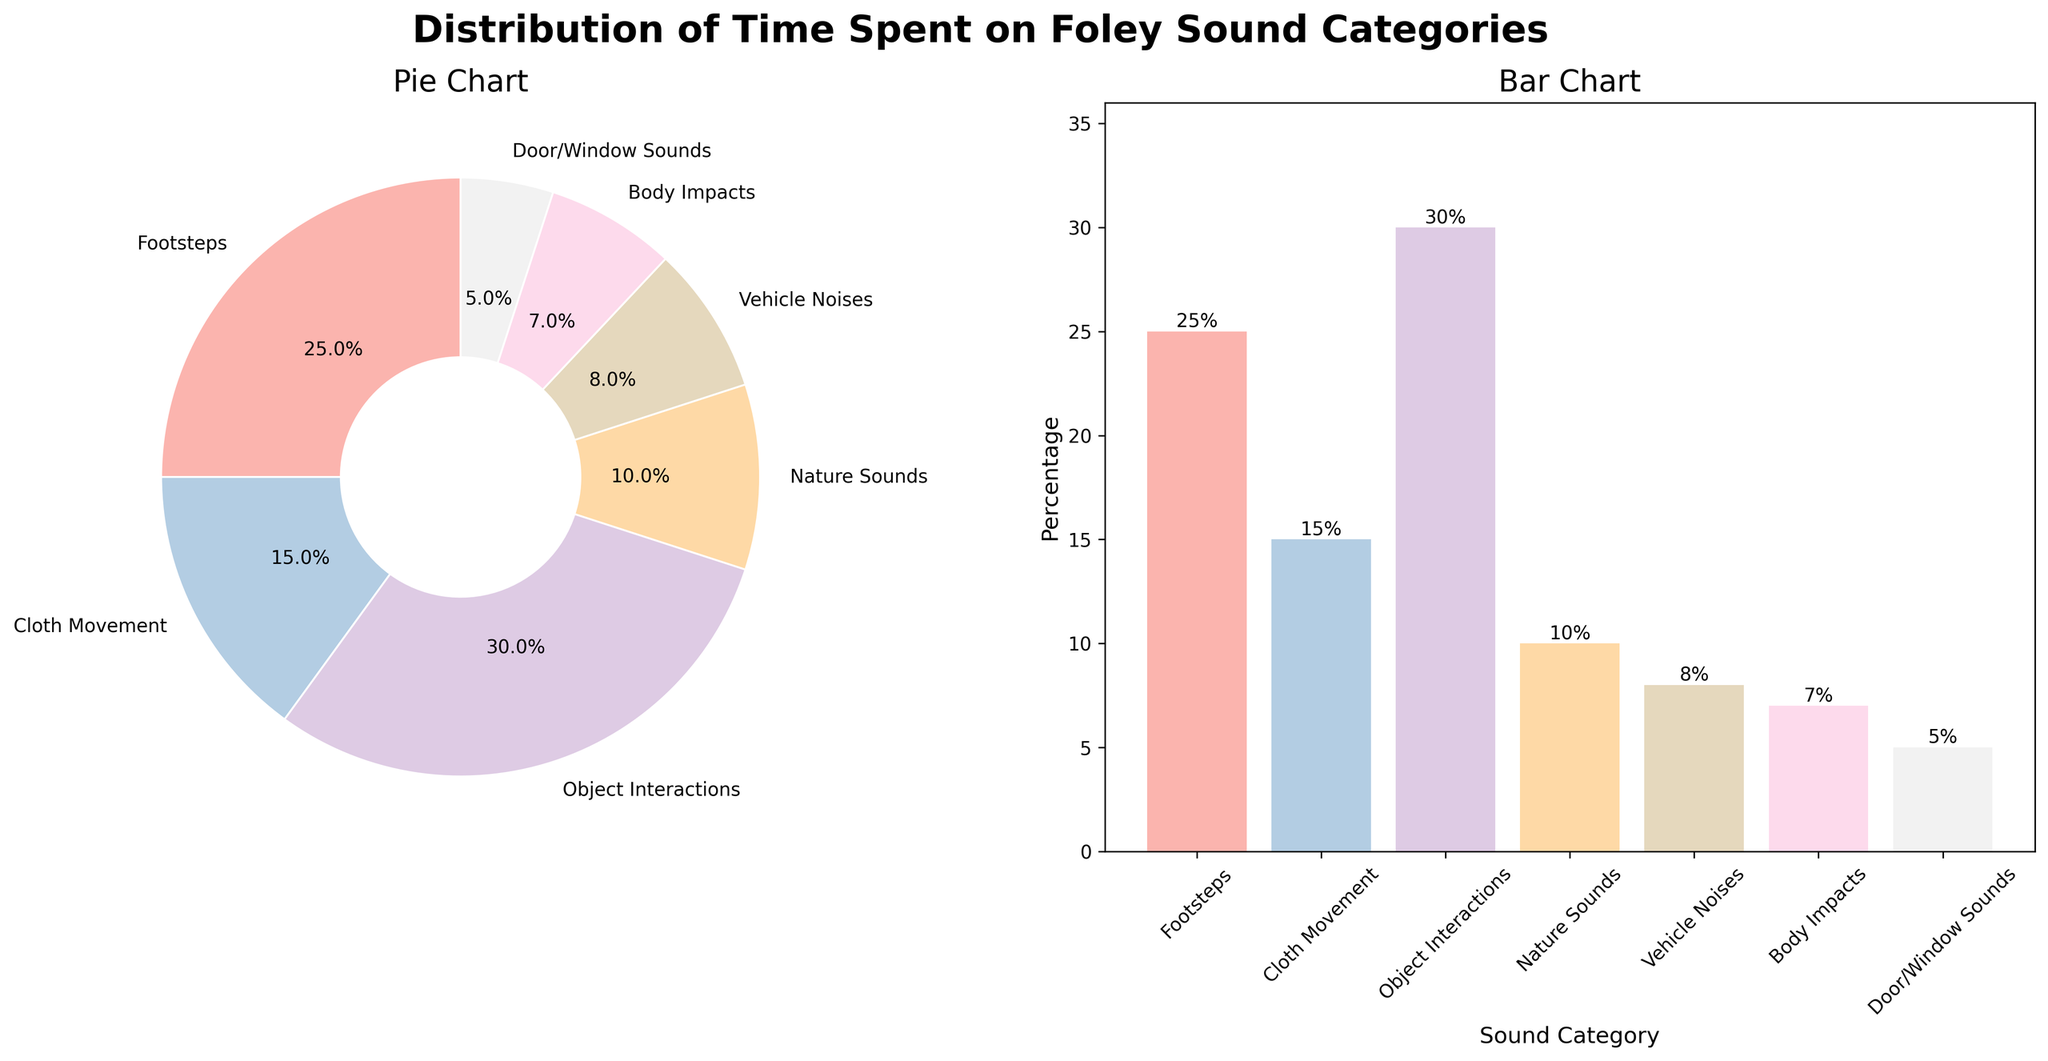What is the sound category with the highest percentage in both charts? By looking at both the pie chart and bar chart, we see that "Object Interactions" has the highest percentage of 30%.
Answer: Object Interactions Which sound category has the least time spent on it? Both charts show that "Door/Window Sounds" has the smallest slice/bar, indicating the least time spent at 5%.
Answer: Door/Window Sounds How much more time is spent on footsteps compared to vehicle noises? The bar chart shows that "Footsteps" is at 25% and "Vehicle Noises" is at 8%. The difference is 25% - 8% = 17%.
Answer: 17% What is the combined percentage of time spent on footsteps and cloth movement? The bar chart shows "Footsteps" at 25% and "Cloth Movement" at 15%. Adding them, we get 25% + 15% = 40%.
Answer: 40% How does the time spent on body impacts compare to nature sounds? The bar chart shows "Body Impacts" at 7% and "Nature Sounds" at 10%. "Nature Sounds" has a higher percentage by 3%.
Answer: Nature Sounds is 3% higher Which segment occupies one-quarter of the pie chart? By looking at the pie chart, the segment labeled "Footsteps" occupies 25% which is one-quarter of 100%.
Answer: Footsteps What is the average percentage of time spent on all sound categories? Sum all the percentages: 25% + 15% + 30% + 10% + 8% + 7% + 5% = 100%. There are 7 categories, so the average is 100% / 7 ≈ 14.3%.
Answer: 14.3% What is the percentage difference between the highest and lowest categories? The highest is "Object Interactions" with 30% and the lowest is "Door/Window Sounds" with 5%. The difference is 30% - 5% = 25%.
Answer: 25% 